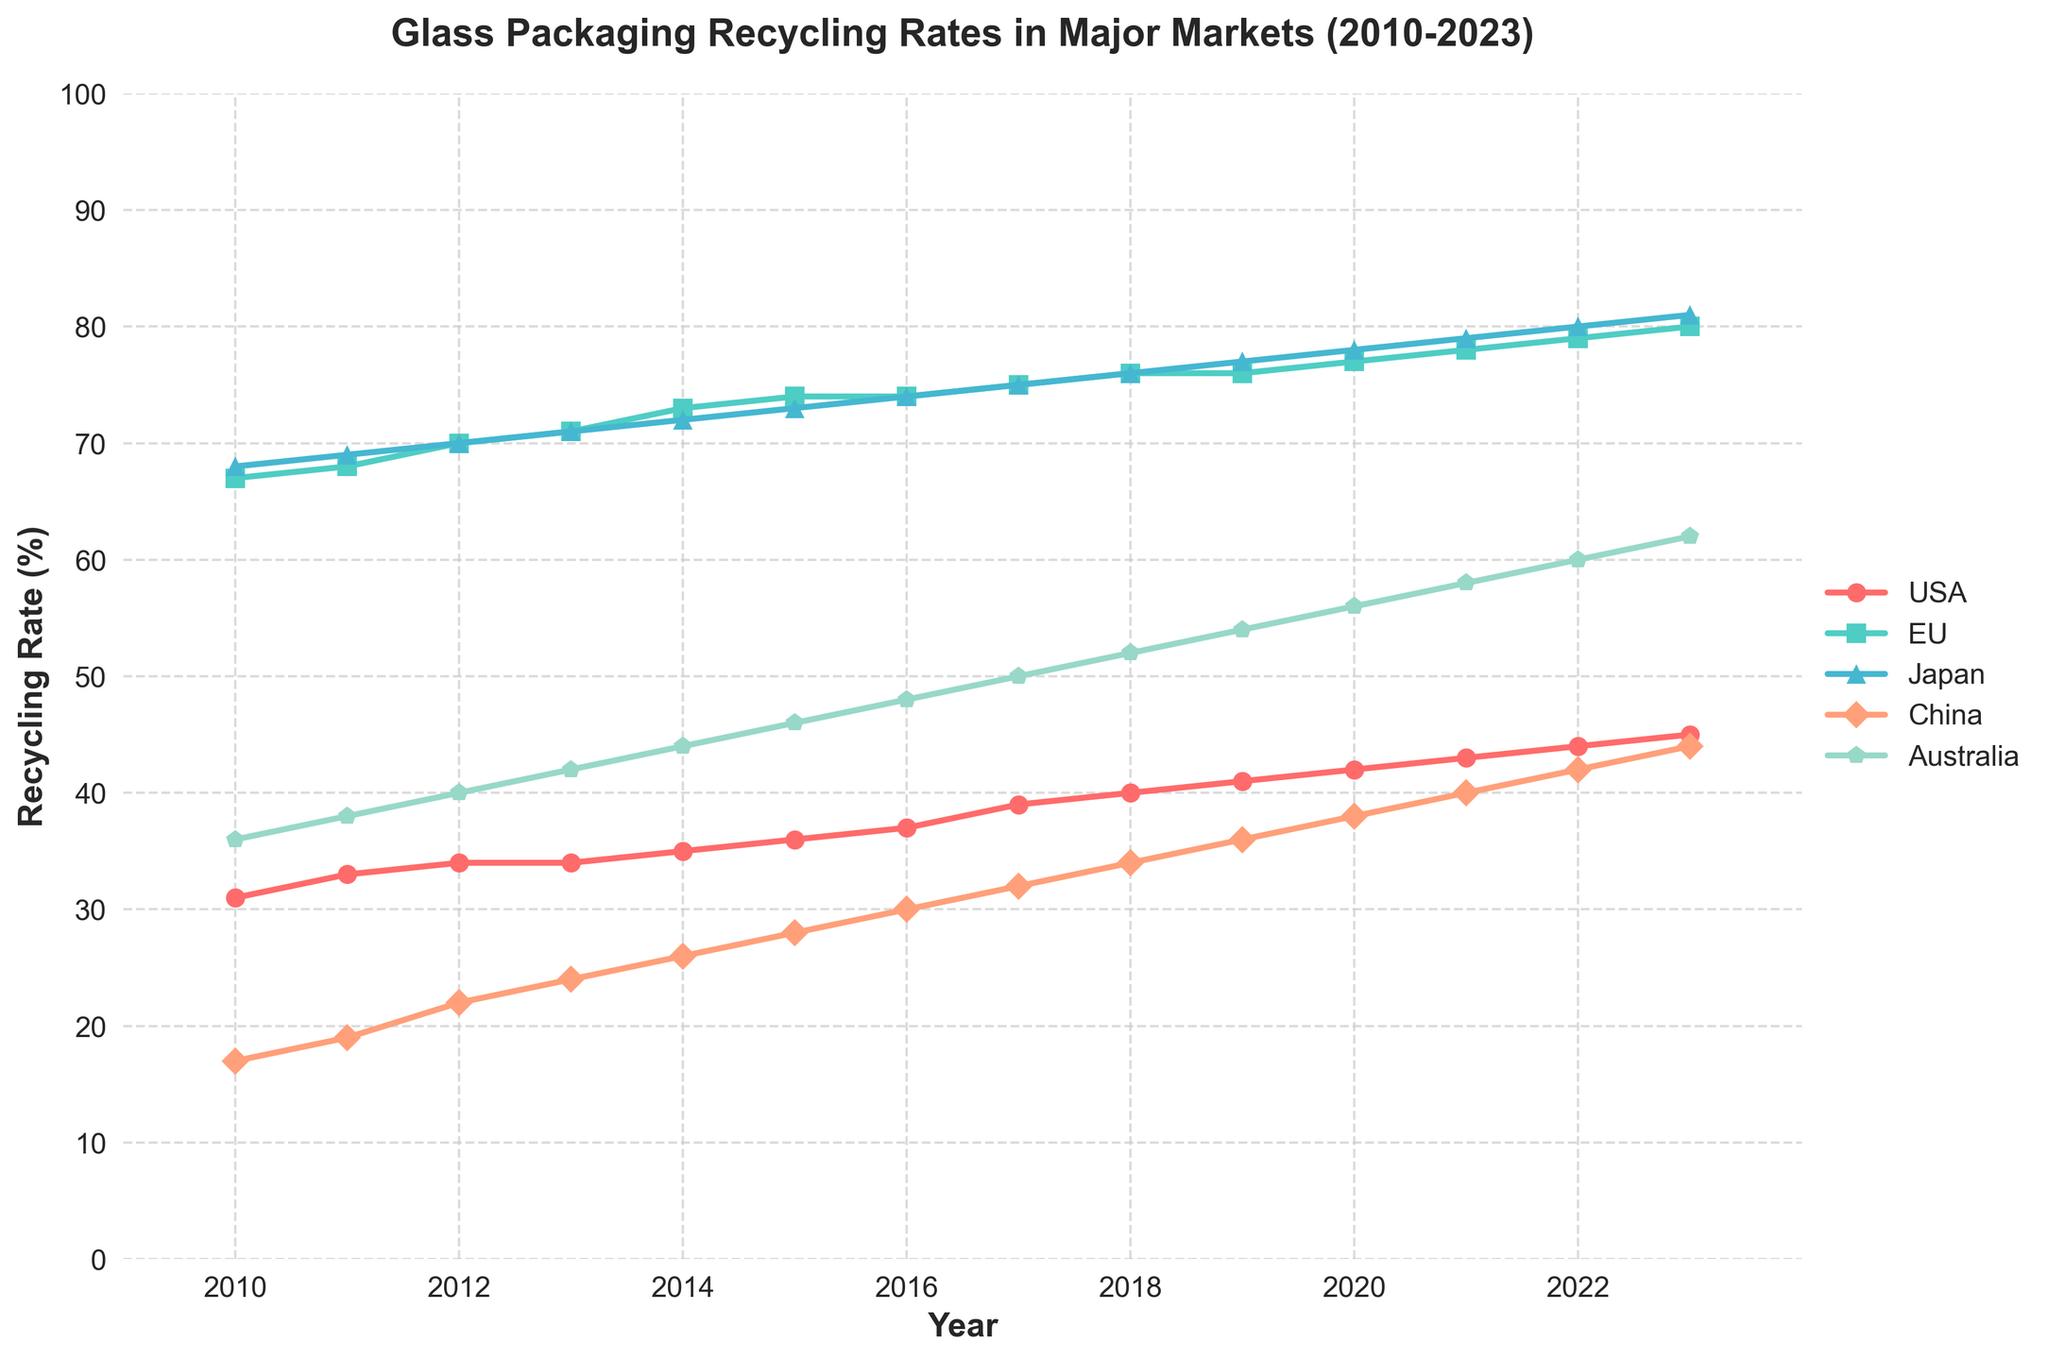Which country had the highest recycling rate for glass packaging materials in 2023? By looking at the line chart, observe the end point of each line for 2023. The highest endpoint represents the country with the highest recycling rate, which is Japan.
Answer: Japan Which year did the USA first surpass a recycling rate of 40%? Follow the USA data line and identify the year where the recycling rate first exceeds 40%. This occurs in 2018.
Answer: 2018 Compare the recycling rates of China and Australia in 2016. Which country had the higher rate? Look for the data points for China and Australia in the year 2016 and compare their heights. China had a recycling rate of 30%, while Australia's rate was 48%. Therefore, Australia had the higher rate.
Answer: Australia By how much did the EU's recycling rate increase from 2010 to 2023? Subtract the recycling rate of the EU in 2010 from the rate in 2023. The increase is 80% - 67% = 13%.
Answer: 13% What is the average recycling rate of Japan from 2010 to 2023? Add up the recycling rates for Japan from each year and divide by the number of years (14). (68 + 69 + 70 + 71 + 72 + 73 + 74 + 75 + 76 + 77 + 78 + 79 + 80 + 81) / 14 = 73.21.
Answer: 73.21 Which market saw the most consistent (least variable) increase in recycling rates over the years? By visually inspecting the smoothness and the slope of the lines, the EU has the most consistent gradual increase, shown by its nearly straight line.
Answer: EU What is the combined recycling rate of the USA and China in 2020? Add the recycling rates of the USA and China for the year 2020. The combined rate is 42% + 38% = 80%.
Answer: 80% Which country's recycling rate showed the steepest increase between 2010 and 2013? Determine the increase in recycling rate for each country between 2010 and 2013. USA: 34 - 31 = 3%, EU: 71 - 67 = 4%, Japan: 71 - 68 = 3%, China: 24 - 17 = 7%, Australia: 42 - 36 = 6%. China had the steepest increase.
Answer: China From 2017 to 2018, which country had the smallest change in recycling rate? Calculate the difference in recycling rates for each country between 2017 and 2018. USA: 40 - 39 = 1%, EU: 76 - 75 = 1%, Japan: 76 - 75 = 1%, China: 34 - 32 = 2%, Australia: 52 - 50 = 2%. The USA, EU, and Japan all had a 1% change.
Answer: USA, EU, Japan 